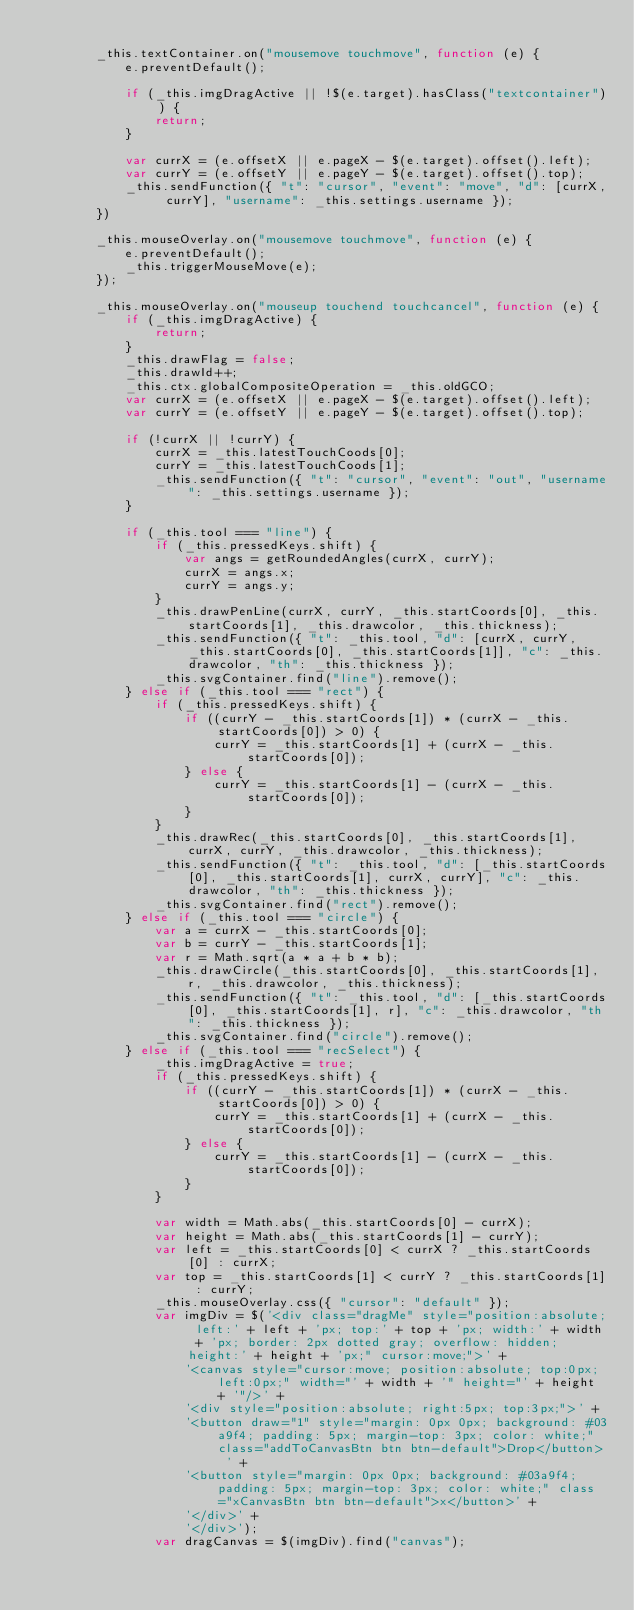<code> <loc_0><loc_0><loc_500><loc_500><_JavaScript_>
        _this.textContainer.on("mousemove touchmove", function (e) {
            e.preventDefault();

            if (_this.imgDragActive || !$(e.target).hasClass("textcontainer")) {
                return;
            }

            var currX = (e.offsetX || e.pageX - $(e.target).offset().left);
            var currY = (e.offsetY || e.pageY - $(e.target).offset().top);
            _this.sendFunction({ "t": "cursor", "event": "move", "d": [currX, currY], "username": _this.settings.username });
        })

        _this.mouseOverlay.on("mousemove touchmove", function (e) {
            e.preventDefault();
            _this.triggerMouseMove(e);
        });

        _this.mouseOverlay.on("mouseup touchend touchcancel", function (e) {
            if (_this.imgDragActive) {
                return;
            }
            _this.drawFlag = false;
            _this.drawId++;
            _this.ctx.globalCompositeOperation = _this.oldGCO;
            var currX = (e.offsetX || e.pageX - $(e.target).offset().left);
            var currY = (e.offsetY || e.pageY - $(e.target).offset().top);

            if (!currX || !currY) {
                currX = _this.latestTouchCoods[0];
                currY = _this.latestTouchCoods[1];
                _this.sendFunction({ "t": "cursor", "event": "out", "username": _this.settings.username });
            }

            if (_this.tool === "line") {
                if (_this.pressedKeys.shift) {
                    var angs = getRoundedAngles(currX, currY);
                    currX = angs.x;
                    currY = angs.y;
                }
                _this.drawPenLine(currX, currY, _this.startCoords[0], _this.startCoords[1], _this.drawcolor, _this.thickness);
                _this.sendFunction({ "t": _this.tool, "d": [currX, currY, _this.startCoords[0], _this.startCoords[1]], "c": _this.drawcolor, "th": _this.thickness });
                _this.svgContainer.find("line").remove();
            } else if (_this.tool === "rect") {
                if (_this.pressedKeys.shift) {
                    if ((currY - _this.startCoords[1]) * (currX - _this.startCoords[0]) > 0) {
                        currY = _this.startCoords[1] + (currX - _this.startCoords[0]);
                    } else {
                        currY = _this.startCoords[1] - (currX - _this.startCoords[0]);
                    }
                }
                _this.drawRec(_this.startCoords[0], _this.startCoords[1], currX, currY, _this.drawcolor, _this.thickness);
                _this.sendFunction({ "t": _this.tool, "d": [_this.startCoords[0], _this.startCoords[1], currX, currY], "c": _this.drawcolor, "th": _this.thickness });
                _this.svgContainer.find("rect").remove();
            } else if (_this.tool === "circle") {
                var a = currX - _this.startCoords[0];
                var b = currY - _this.startCoords[1];
                var r = Math.sqrt(a * a + b * b);
                _this.drawCircle(_this.startCoords[0], _this.startCoords[1], r, _this.drawcolor, _this.thickness);
                _this.sendFunction({ "t": _this.tool, "d": [_this.startCoords[0], _this.startCoords[1], r], "c": _this.drawcolor, "th": _this.thickness });
                _this.svgContainer.find("circle").remove();
            } else if (_this.tool === "recSelect") {
                _this.imgDragActive = true;
                if (_this.pressedKeys.shift) {
                    if ((currY - _this.startCoords[1]) * (currX - _this.startCoords[0]) > 0) {
                        currY = _this.startCoords[1] + (currX - _this.startCoords[0]);
                    } else {
                        currY = _this.startCoords[1] - (currX - _this.startCoords[0]);
                    }
                }

                var width = Math.abs(_this.startCoords[0] - currX);
                var height = Math.abs(_this.startCoords[1] - currY);
                var left = _this.startCoords[0] < currX ? _this.startCoords[0] : currX;
                var top = _this.startCoords[1] < currY ? _this.startCoords[1] : currY;
                _this.mouseOverlay.css({ "cursor": "default" });
                var imgDiv = $('<div class="dragMe" style="position:absolute; left:' + left + 'px; top:' + top + 'px; width:' + width + 'px; border: 2px dotted gray; overflow: hidden; height:' + height + 'px;" cursor:move;">' +
                    '<canvas style="cursor:move; position:absolute; top:0px; left:0px;" width="' + width + '" height="' + height + '"/>' +
                    '<div style="position:absolute; right:5px; top:3px;">' +
                    '<button draw="1" style="margin: 0px 0px; background: #03a9f4; padding: 5px; margin-top: 3px; color: white;" class="addToCanvasBtn btn btn-default">Drop</button> ' +
                    '<button style="margin: 0px 0px; background: #03a9f4; padding: 5px; margin-top: 3px; color: white;" class="xCanvasBtn btn btn-default">x</button>' +
                    '</div>' +
                    '</div>');
                var dragCanvas = $(imgDiv).find("canvas");</code> 